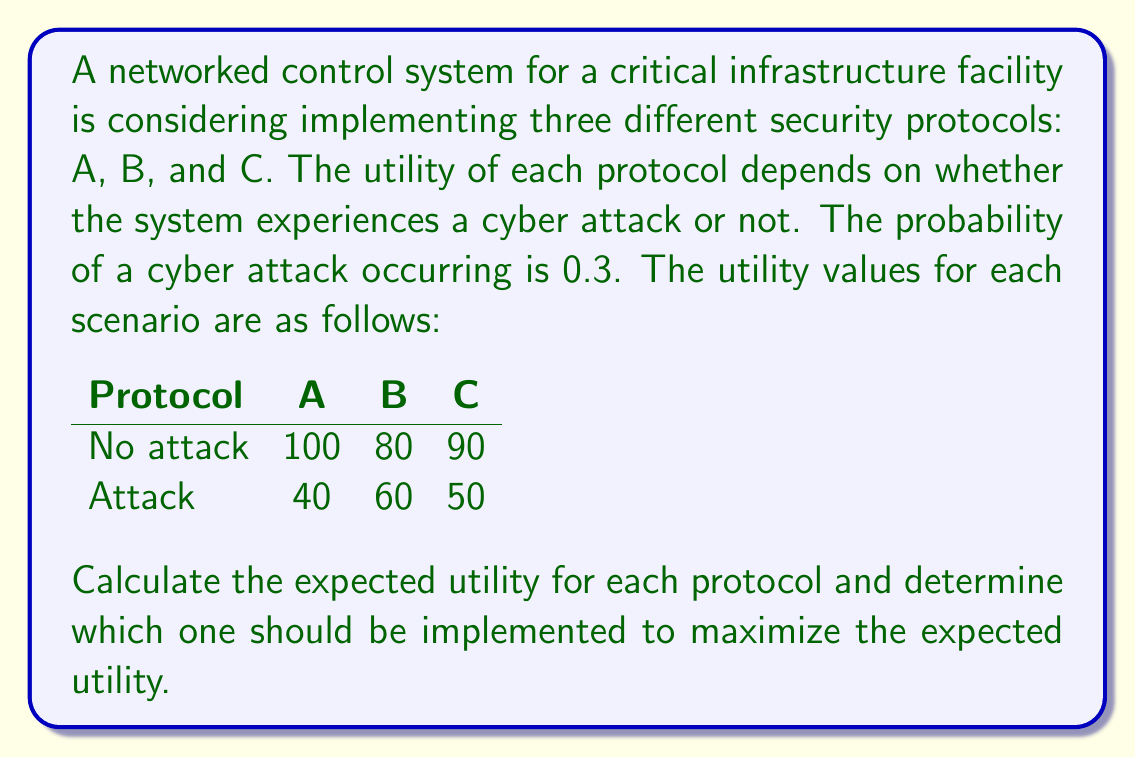Give your solution to this math problem. To solve this problem, we need to calculate the expected utility for each protocol using the given probabilities and utility values. The expected utility is the sum of the utilities in each scenario multiplied by their respective probabilities.

Let's define:
$p(attack) = 0.3$
$p(no attack) = 1 - p(attack) = 0.7$

For each protocol, we'll calculate the expected utility (EU) using the formula:

$EU = U(no attack) \cdot p(no attack) + U(attack) \cdot p(attack)$

Protocol A:
$EU_A = 100 \cdot 0.7 + 40 \cdot 0.3$
$EU_A = 70 + 12 = 82$

Protocol B:
$EU_B = 80 \cdot 0.7 + 60 \cdot 0.3$
$EU_B = 56 + 18 = 74$

Protocol C:
$EU_C = 90 \cdot 0.7 + 50 \cdot 0.3$
$EU_C = 63 + 15 = 78$

Comparing the expected utilities:
$EU_A = 82$
$EU_B = 74$
$EU_C = 78$

We can see that Protocol A has the highest expected utility.
Answer: The expected utilities for each protocol are:
Protocol A: 82
Protocol B: 74
Protocol C: 78

Protocol A should be implemented to maximize the expected utility. 